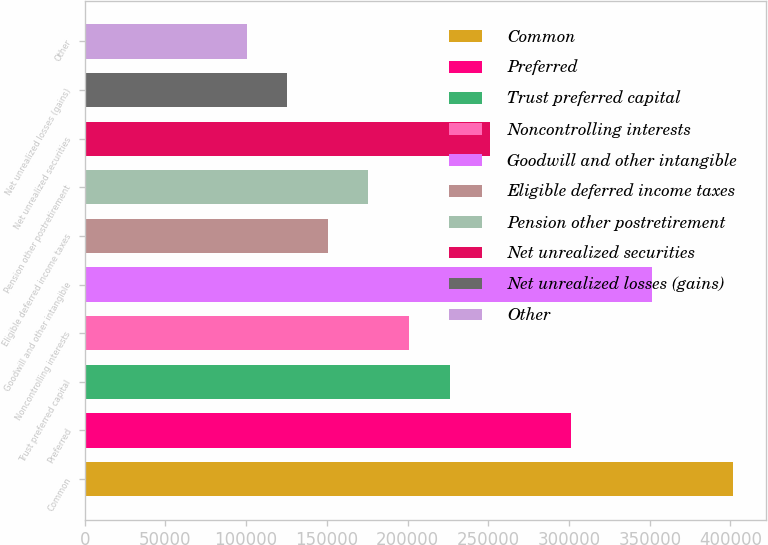<chart> <loc_0><loc_0><loc_500><loc_500><bar_chart><fcel>Common<fcel>Preferred<fcel>Trust preferred capital<fcel>Noncontrolling interests<fcel>Goodwill and other intangible<fcel>Eligible deferred income taxes<fcel>Pension other postretirement<fcel>Net unrealized securities<fcel>Net unrealized losses (gains)<fcel>Other<nl><fcel>401767<fcel>301326<fcel>225996<fcel>200886<fcel>351546<fcel>150666<fcel>175776<fcel>251106<fcel>125555<fcel>100445<nl></chart> 